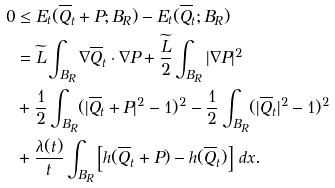<formula> <loc_0><loc_0><loc_500><loc_500>0 & \leq E _ { t } ( \overline { Q } _ { t } + P ; B _ { R } ) - E _ { t } ( \overline { Q } _ { t } ; B _ { R } ) \\ & = \widetilde { L } \int _ { B _ { R } } \nabla \overline { Q } _ { t } \cdot \nabla P + \frac { \widetilde { L } } { 2 } \int _ { B _ { R } } | \nabla P | ^ { 2 } \\ & + \frac { 1 } { 2 } \int _ { B _ { R } } ( | \overline { Q } _ { t } + P | ^ { 2 } - 1 ) ^ { 2 } - \frac { 1 } { 2 } \int _ { B _ { R } } ( | \overline { Q } _ { t } | ^ { 2 } - 1 ) ^ { 2 } \\ & + \frac { \lambda ( t ) } { t } \int _ { B _ { R } } \left [ h ( \overline { Q } _ { t } + P ) - h ( \overline { Q } _ { t } ) \right ] \, d x .</formula> 